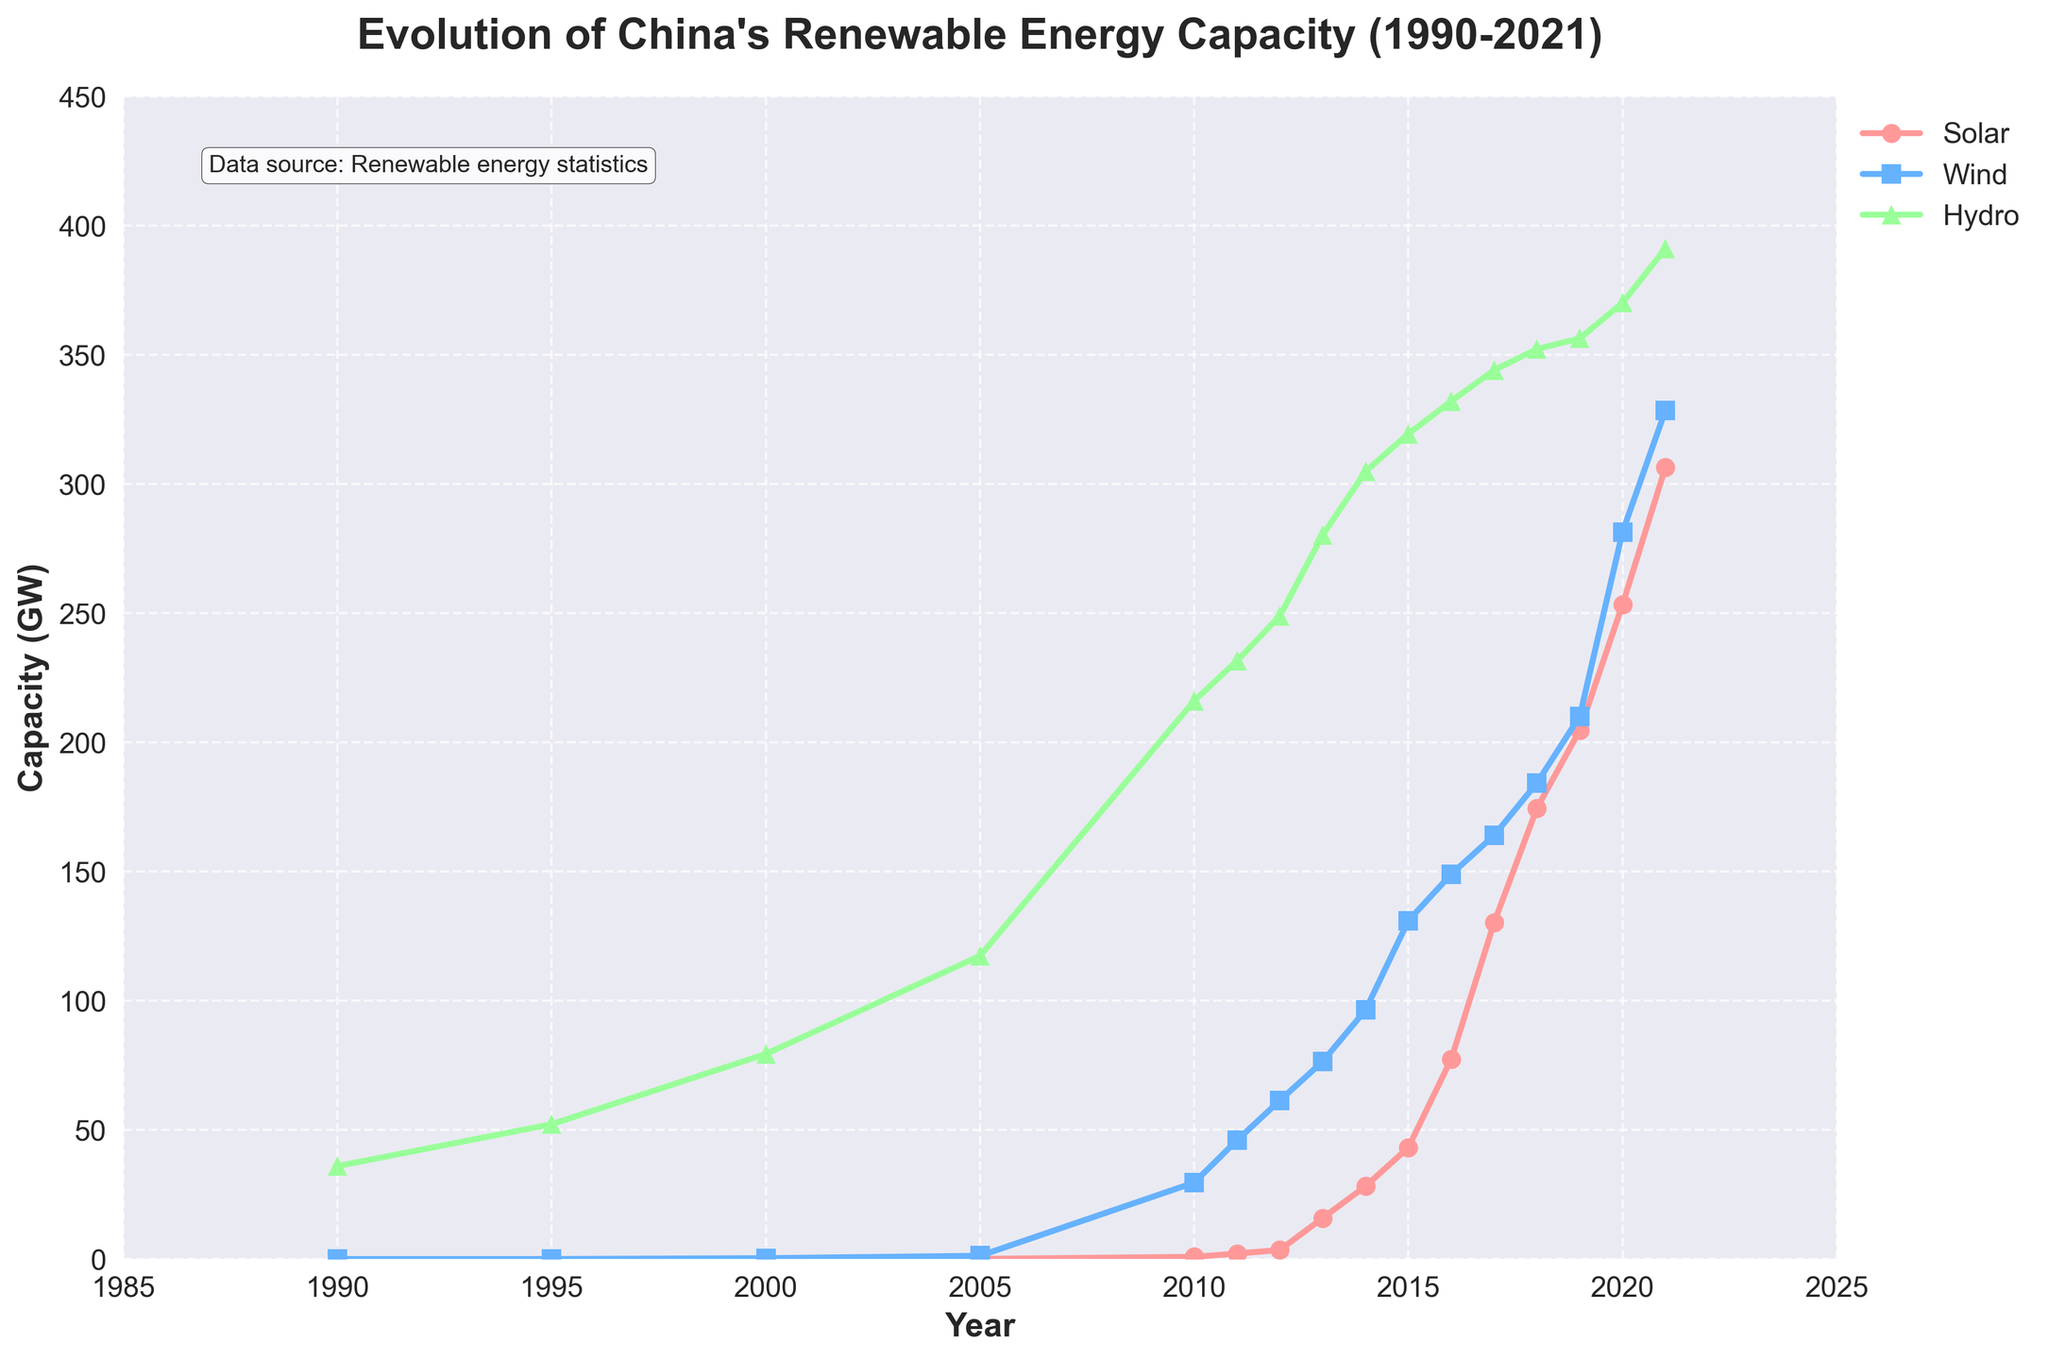What was the capacity of solar energy in 2010? According to the figure, the capacity of solar energy in 2010 is shown on the y-axis for the corresponding year 2010 on the x-axis. The marker representing solar energy aligns with approximately 0.86 GW.
Answer: 0.86 GW Which renewable energy source had the highest capacity in 2005? Observing the figure at the year mark 2005, the three colored markers representing solar, wind, and hydro energy can be compared. Hydro energy is represented by the highest marker at around 117.4 GW.
Answer: Hydro How much did the wind energy capacity increase between 2010 and 2015? First, locate the wind energy capacity at 2010 which is around 29.6 GW and at 2015 which is approximately 131.0 GW. Calculate the difference (131.0 - 29.6).
Answer: 101.4 GW When did solar energy capacity first surpass 100 GW? Follow the plot line of solar energy and find the year at which it crosses the 100 GW mark on the y-axis. This appears to occur between 2016 and 2017.
Answer: 2017 Between 1995 and 2000, which renewable energy source experienced a greater increase in capacity: solar or wind? For solar, the increase is from 0 GW in 1995 to 0.02 GW in 2000. For wind, the increase is from 0 GW in 1995 to 0.34 GW in 2000. The difference for solar is 0.02 GW and for wind is 0.34 GW. Wind had a higher increase.
Answer: Wind What is the average capacity of hydro energy between 2010 and 2021? Sum the hydro energy capacities from 2010 to 2021, then divide by the number of years (2021 - 2010 + 1 = 12). (216.1 + 231.6 + 249.0 + 280.3 + 304.9 + 319.5 + 332.1 + 344.1 + 352.3 + 356.4 + 370.2 + 391.2) / 12 = 300.65 GW
Answer: 300.65 GW Which year saw the largest annual increase in solar energy capacity? Examine the differences in solar energy capacities year-over-year and identify the largest change. The largest jump is between 2015 and 2016 from 43.2 GW to 77.4 GW, an increase of 34.2 GW.
Answer: 2016 By how much did hydro energy capacity increase from 1995 to 2021? Find the hydro capacities for both years and compute the difference (391.2 GW in 2021 - 52.2 GW in 1995).
Answer: 339 GW 